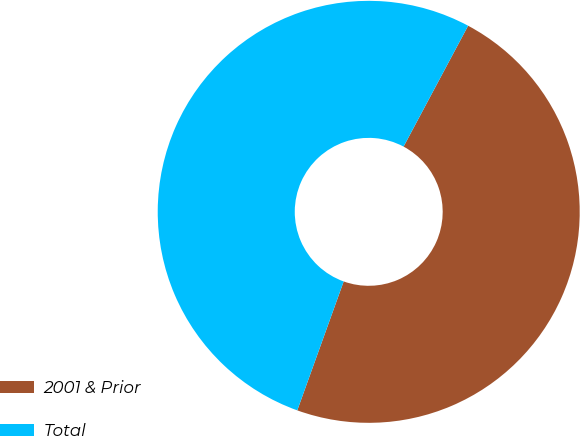Convert chart. <chart><loc_0><loc_0><loc_500><loc_500><pie_chart><fcel>2001 & Prior<fcel>Total<nl><fcel>47.69%<fcel>52.31%<nl></chart> 